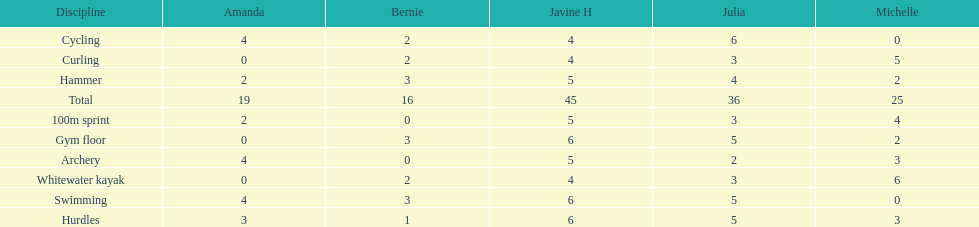Who scored the least on whitewater kayak? Amanda. 